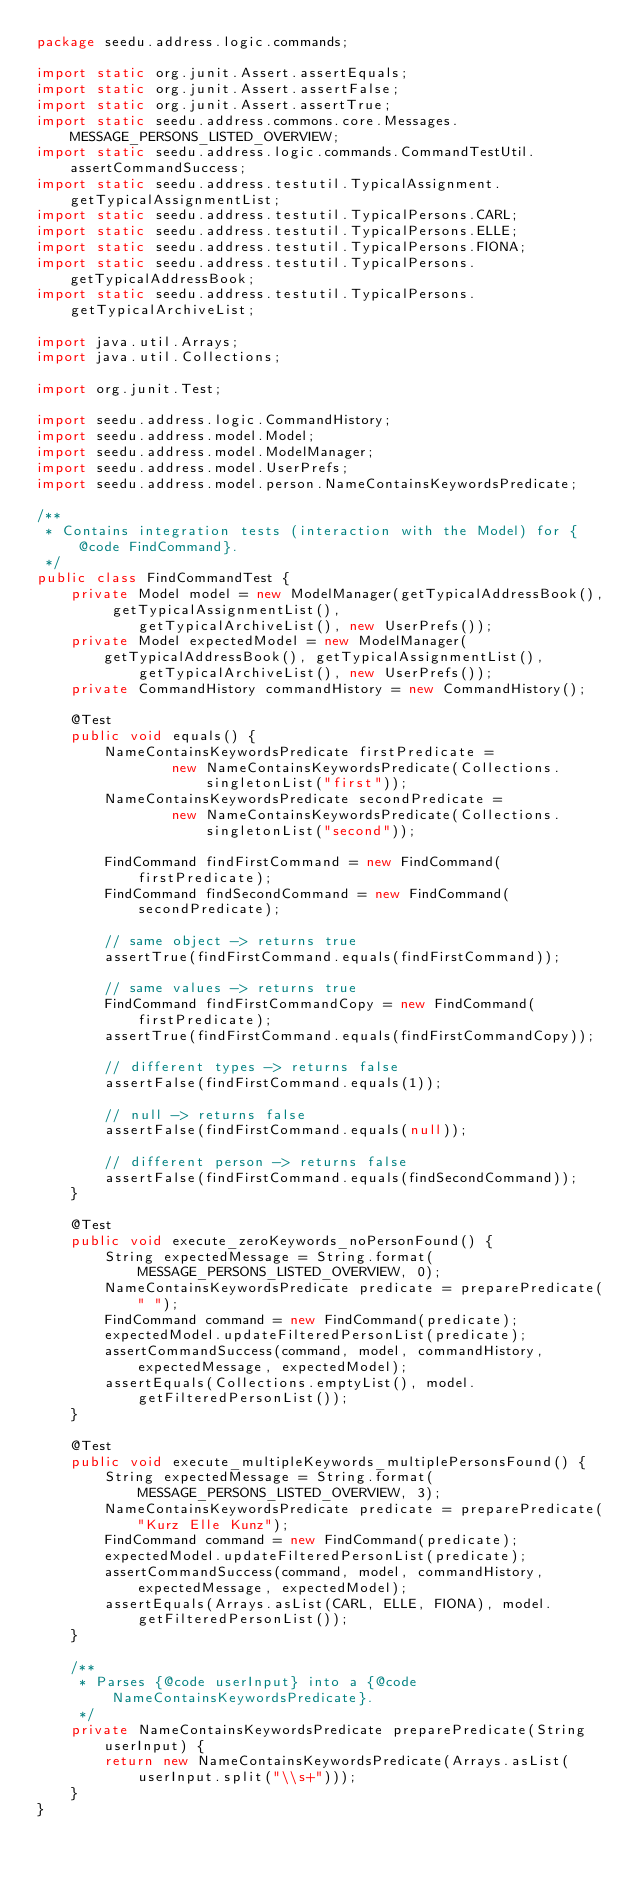<code> <loc_0><loc_0><loc_500><loc_500><_Java_>package seedu.address.logic.commands;

import static org.junit.Assert.assertEquals;
import static org.junit.Assert.assertFalse;
import static org.junit.Assert.assertTrue;
import static seedu.address.commons.core.Messages.MESSAGE_PERSONS_LISTED_OVERVIEW;
import static seedu.address.logic.commands.CommandTestUtil.assertCommandSuccess;
import static seedu.address.testutil.TypicalAssignment.getTypicalAssignmentList;
import static seedu.address.testutil.TypicalPersons.CARL;
import static seedu.address.testutil.TypicalPersons.ELLE;
import static seedu.address.testutil.TypicalPersons.FIONA;
import static seedu.address.testutil.TypicalPersons.getTypicalAddressBook;
import static seedu.address.testutil.TypicalPersons.getTypicalArchiveList;

import java.util.Arrays;
import java.util.Collections;

import org.junit.Test;

import seedu.address.logic.CommandHistory;
import seedu.address.model.Model;
import seedu.address.model.ModelManager;
import seedu.address.model.UserPrefs;
import seedu.address.model.person.NameContainsKeywordsPredicate;

/**
 * Contains integration tests (interaction with the Model) for {@code FindCommand}.
 */
public class FindCommandTest {
    private Model model = new ModelManager(getTypicalAddressBook(), getTypicalAssignmentList(),
            getTypicalArchiveList(), new UserPrefs());
    private Model expectedModel = new ModelManager(getTypicalAddressBook(), getTypicalAssignmentList(),
            getTypicalArchiveList(), new UserPrefs());
    private CommandHistory commandHistory = new CommandHistory();

    @Test
    public void equals() {
        NameContainsKeywordsPredicate firstPredicate =
                new NameContainsKeywordsPredicate(Collections.singletonList("first"));
        NameContainsKeywordsPredicate secondPredicate =
                new NameContainsKeywordsPredicate(Collections.singletonList("second"));

        FindCommand findFirstCommand = new FindCommand(firstPredicate);
        FindCommand findSecondCommand = new FindCommand(secondPredicate);

        // same object -> returns true
        assertTrue(findFirstCommand.equals(findFirstCommand));

        // same values -> returns true
        FindCommand findFirstCommandCopy = new FindCommand(firstPredicate);
        assertTrue(findFirstCommand.equals(findFirstCommandCopy));

        // different types -> returns false
        assertFalse(findFirstCommand.equals(1));

        // null -> returns false
        assertFalse(findFirstCommand.equals(null));

        // different person -> returns false
        assertFalse(findFirstCommand.equals(findSecondCommand));
    }

    @Test
    public void execute_zeroKeywords_noPersonFound() {
        String expectedMessage = String.format(MESSAGE_PERSONS_LISTED_OVERVIEW, 0);
        NameContainsKeywordsPredicate predicate = preparePredicate(" ");
        FindCommand command = new FindCommand(predicate);
        expectedModel.updateFilteredPersonList(predicate);
        assertCommandSuccess(command, model, commandHistory, expectedMessage, expectedModel);
        assertEquals(Collections.emptyList(), model.getFilteredPersonList());
    }

    @Test
    public void execute_multipleKeywords_multiplePersonsFound() {
        String expectedMessage = String.format(MESSAGE_PERSONS_LISTED_OVERVIEW, 3);
        NameContainsKeywordsPredicate predicate = preparePredicate("Kurz Elle Kunz");
        FindCommand command = new FindCommand(predicate);
        expectedModel.updateFilteredPersonList(predicate);
        assertCommandSuccess(command, model, commandHistory, expectedMessage, expectedModel);
        assertEquals(Arrays.asList(CARL, ELLE, FIONA), model.getFilteredPersonList());
    }

    /**
     * Parses {@code userInput} into a {@code NameContainsKeywordsPredicate}.
     */
    private NameContainsKeywordsPredicate preparePredicate(String userInput) {
        return new NameContainsKeywordsPredicate(Arrays.asList(userInput.split("\\s+")));
    }
}
</code> 